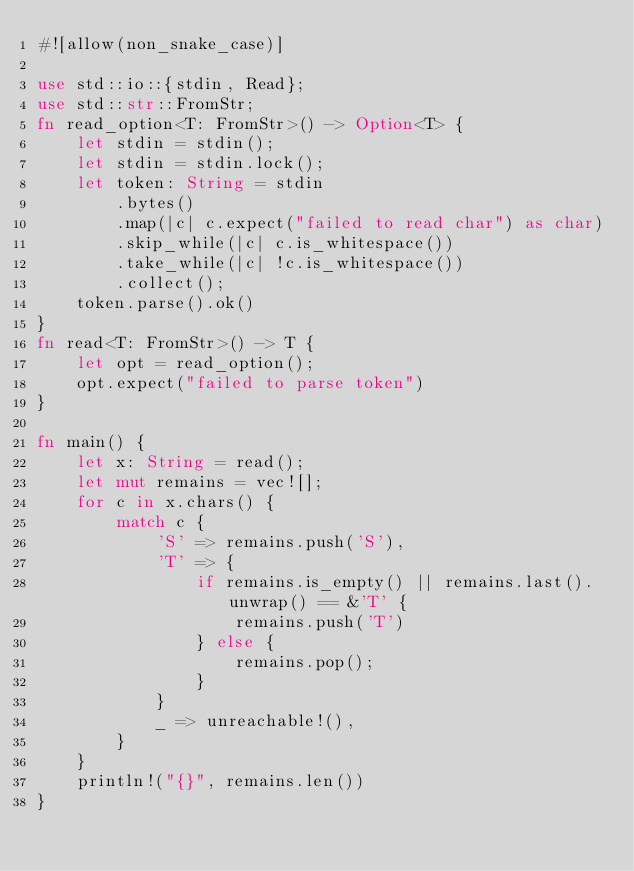Convert code to text. <code><loc_0><loc_0><loc_500><loc_500><_Rust_>#![allow(non_snake_case)]

use std::io::{stdin, Read};
use std::str::FromStr;
fn read_option<T: FromStr>() -> Option<T> {
    let stdin = stdin();
    let stdin = stdin.lock();
    let token: String = stdin
        .bytes()
        .map(|c| c.expect("failed to read char") as char)
        .skip_while(|c| c.is_whitespace())
        .take_while(|c| !c.is_whitespace())
        .collect();
    token.parse().ok()
}
fn read<T: FromStr>() -> T {
    let opt = read_option();
    opt.expect("failed to parse token")
}

fn main() {
    let x: String = read();
    let mut remains = vec![];
    for c in x.chars() {
        match c {
            'S' => remains.push('S'),
            'T' => {
                if remains.is_empty() || remains.last().unwrap() == &'T' {
                    remains.push('T')
                } else {
                    remains.pop();
                }
            }
            _ => unreachable!(),
        }
    }
    println!("{}", remains.len())
}
</code> 